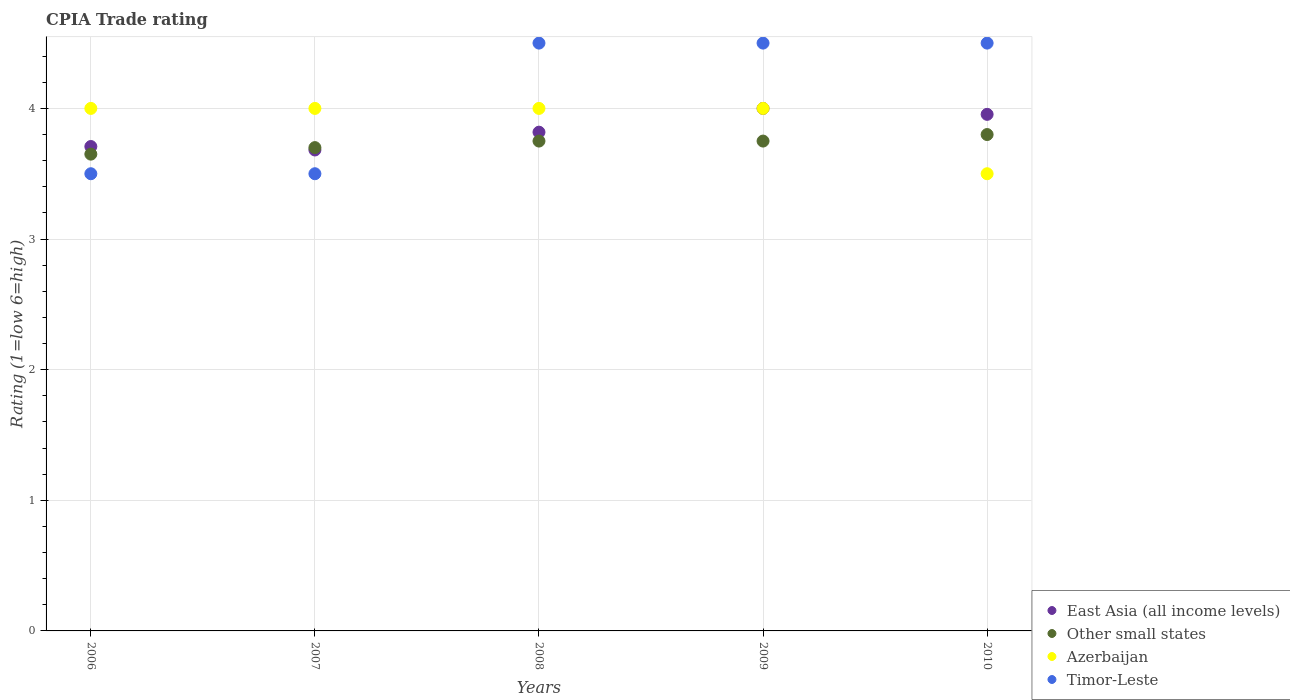How many different coloured dotlines are there?
Offer a terse response. 4. Across all years, what is the maximum CPIA rating in Timor-Leste?
Your answer should be very brief. 4.5. Across all years, what is the minimum CPIA rating in East Asia (all income levels)?
Offer a terse response. 3.68. What is the total CPIA rating in East Asia (all income levels) in the graph?
Offer a very short reply. 19.16. What is the difference between the CPIA rating in East Asia (all income levels) in 2007 and that in 2009?
Ensure brevity in your answer.  -0.32. What is the difference between the CPIA rating in Other small states in 2007 and the CPIA rating in East Asia (all income levels) in 2008?
Your response must be concise. -0.12. What is the average CPIA rating in Timor-Leste per year?
Make the answer very short. 4.1. In the year 2009, what is the difference between the CPIA rating in Other small states and CPIA rating in East Asia (all income levels)?
Offer a very short reply. -0.25. In how many years, is the CPIA rating in Other small states greater than 1?
Offer a very short reply. 5. What is the ratio of the CPIA rating in Timor-Leste in 2008 to that in 2010?
Make the answer very short. 1. What is the difference between the highest and the lowest CPIA rating in Other small states?
Your answer should be compact. 0.15. Is the sum of the CPIA rating in Azerbaijan in 2006 and 2008 greater than the maximum CPIA rating in East Asia (all income levels) across all years?
Keep it short and to the point. Yes. Is it the case that in every year, the sum of the CPIA rating in Azerbaijan and CPIA rating in East Asia (all income levels)  is greater than the sum of CPIA rating in Other small states and CPIA rating in Timor-Leste?
Make the answer very short. No. Does the CPIA rating in Other small states monotonically increase over the years?
Ensure brevity in your answer.  No. Is the CPIA rating in Other small states strictly greater than the CPIA rating in Azerbaijan over the years?
Ensure brevity in your answer.  No. Is the CPIA rating in East Asia (all income levels) strictly less than the CPIA rating in Timor-Leste over the years?
Give a very brief answer. No. How many years are there in the graph?
Your answer should be very brief. 5. Does the graph contain any zero values?
Offer a terse response. No. How many legend labels are there?
Ensure brevity in your answer.  4. How are the legend labels stacked?
Offer a very short reply. Vertical. What is the title of the graph?
Provide a short and direct response. CPIA Trade rating. What is the label or title of the Y-axis?
Keep it short and to the point. Rating (1=low 6=high). What is the Rating (1=low 6=high) of East Asia (all income levels) in 2006?
Keep it short and to the point. 3.71. What is the Rating (1=low 6=high) in Other small states in 2006?
Your answer should be compact. 3.65. What is the Rating (1=low 6=high) in Azerbaijan in 2006?
Ensure brevity in your answer.  4. What is the Rating (1=low 6=high) in East Asia (all income levels) in 2007?
Your answer should be compact. 3.68. What is the Rating (1=low 6=high) in East Asia (all income levels) in 2008?
Your response must be concise. 3.82. What is the Rating (1=low 6=high) of Other small states in 2008?
Keep it short and to the point. 3.75. What is the Rating (1=low 6=high) in Timor-Leste in 2008?
Provide a succinct answer. 4.5. What is the Rating (1=low 6=high) of East Asia (all income levels) in 2009?
Your response must be concise. 4. What is the Rating (1=low 6=high) in Other small states in 2009?
Make the answer very short. 3.75. What is the Rating (1=low 6=high) of East Asia (all income levels) in 2010?
Offer a very short reply. 3.95. What is the Rating (1=low 6=high) of Other small states in 2010?
Your answer should be very brief. 3.8. What is the Rating (1=low 6=high) of Azerbaijan in 2010?
Make the answer very short. 3.5. What is the Rating (1=low 6=high) in Timor-Leste in 2010?
Offer a terse response. 4.5. Across all years, what is the maximum Rating (1=low 6=high) in East Asia (all income levels)?
Your response must be concise. 4. Across all years, what is the maximum Rating (1=low 6=high) of Timor-Leste?
Provide a succinct answer. 4.5. Across all years, what is the minimum Rating (1=low 6=high) of East Asia (all income levels)?
Offer a terse response. 3.68. Across all years, what is the minimum Rating (1=low 6=high) of Other small states?
Your answer should be very brief. 3.65. Across all years, what is the minimum Rating (1=low 6=high) of Timor-Leste?
Provide a succinct answer. 3.5. What is the total Rating (1=low 6=high) in East Asia (all income levels) in the graph?
Give a very brief answer. 19.16. What is the total Rating (1=low 6=high) of Other small states in the graph?
Offer a very short reply. 18.65. What is the total Rating (1=low 6=high) in Azerbaijan in the graph?
Give a very brief answer. 19.5. What is the difference between the Rating (1=low 6=high) in East Asia (all income levels) in 2006 and that in 2007?
Offer a terse response. 0.03. What is the difference between the Rating (1=low 6=high) in East Asia (all income levels) in 2006 and that in 2008?
Ensure brevity in your answer.  -0.11. What is the difference between the Rating (1=low 6=high) in Other small states in 2006 and that in 2008?
Your answer should be very brief. -0.1. What is the difference between the Rating (1=low 6=high) of Azerbaijan in 2006 and that in 2008?
Make the answer very short. 0. What is the difference between the Rating (1=low 6=high) in Timor-Leste in 2006 and that in 2008?
Offer a terse response. -1. What is the difference between the Rating (1=low 6=high) in East Asia (all income levels) in 2006 and that in 2009?
Ensure brevity in your answer.  -0.29. What is the difference between the Rating (1=low 6=high) of Azerbaijan in 2006 and that in 2009?
Give a very brief answer. 0. What is the difference between the Rating (1=low 6=high) in East Asia (all income levels) in 2006 and that in 2010?
Keep it short and to the point. -0.25. What is the difference between the Rating (1=low 6=high) in Other small states in 2006 and that in 2010?
Ensure brevity in your answer.  -0.15. What is the difference between the Rating (1=low 6=high) of Timor-Leste in 2006 and that in 2010?
Provide a succinct answer. -1. What is the difference between the Rating (1=low 6=high) in East Asia (all income levels) in 2007 and that in 2008?
Provide a succinct answer. -0.14. What is the difference between the Rating (1=low 6=high) of Azerbaijan in 2007 and that in 2008?
Your response must be concise. 0. What is the difference between the Rating (1=low 6=high) in East Asia (all income levels) in 2007 and that in 2009?
Ensure brevity in your answer.  -0.32. What is the difference between the Rating (1=low 6=high) in Other small states in 2007 and that in 2009?
Make the answer very short. -0.05. What is the difference between the Rating (1=low 6=high) of Timor-Leste in 2007 and that in 2009?
Offer a very short reply. -1. What is the difference between the Rating (1=low 6=high) in East Asia (all income levels) in 2007 and that in 2010?
Provide a succinct answer. -0.27. What is the difference between the Rating (1=low 6=high) in Other small states in 2007 and that in 2010?
Keep it short and to the point. -0.1. What is the difference between the Rating (1=low 6=high) of East Asia (all income levels) in 2008 and that in 2009?
Ensure brevity in your answer.  -0.18. What is the difference between the Rating (1=low 6=high) of Azerbaijan in 2008 and that in 2009?
Provide a succinct answer. 0. What is the difference between the Rating (1=low 6=high) in East Asia (all income levels) in 2008 and that in 2010?
Give a very brief answer. -0.14. What is the difference between the Rating (1=low 6=high) in Other small states in 2008 and that in 2010?
Your response must be concise. -0.05. What is the difference between the Rating (1=low 6=high) of Azerbaijan in 2008 and that in 2010?
Ensure brevity in your answer.  0.5. What is the difference between the Rating (1=low 6=high) in Timor-Leste in 2008 and that in 2010?
Ensure brevity in your answer.  0. What is the difference between the Rating (1=low 6=high) of East Asia (all income levels) in 2009 and that in 2010?
Ensure brevity in your answer.  0.05. What is the difference between the Rating (1=low 6=high) in East Asia (all income levels) in 2006 and the Rating (1=low 6=high) in Other small states in 2007?
Provide a succinct answer. 0.01. What is the difference between the Rating (1=low 6=high) in East Asia (all income levels) in 2006 and the Rating (1=low 6=high) in Azerbaijan in 2007?
Keep it short and to the point. -0.29. What is the difference between the Rating (1=low 6=high) of East Asia (all income levels) in 2006 and the Rating (1=low 6=high) of Timor-Leste in 2007?
Provide a short and direct response. 0.21. What is the difference between the Rating (1=low 6=high) in Other small states in 2006 and the Rating (1=low 6=high) in Azerbaijan in 2007?
Make the answer very short. -0.35. What is the difference between the Rating (1=low 6=high) in Other small states in 2006 and the Rating (1=low 6=high) in Timor-Leste in 2007?
Offer a terse response. 0.15. What is the difference between the Rating (1=low 6=high) in East Asia (all income levels) in 2006 and the Rating (1=low 6=high) in Other small states in 2008?
Your response must be concise. -0.04. What is the difference between the Rating (1=low 6=high) in East Asia (all income levels) in 2006 and the Rating (1=low 6=high) in Azerbaijan in 2008?
Offer a very short reply. -0.29. What is the difference between the Rating (1=low 6=high) of East Asia (all income levels) in 2006 and the Rating (1=low 6=high) of Timor-Leste in 2008?
Ensure brevity in your answer.  -0.79. What is the difference between the Rating (1=low 6=high) in Other small states in 2006 and the Rating (1=low 6=high) in Azerbaijan in 2008?
Your answer should be compact. -0.35. What is the difference between the Rating (1=low 6=high) of Other small states in 2006 and the Rating (1=low 6=high) of Timor-Leste in 2008?
Your response must be concise. -0.85. What is the difference between the Rating (1=low 6=high) in Azerbaijan in 2006 and the Rating (1=low 6=high) in Timor-Leste in 2008?
Your answer should be very brief. -0.5. What is the difference between the Rating (1=low 6=high) of East Asia (all income levels) in 2006 and the Rating (1=low 6=high) of Other small states in 2009?
Give a very brief answer. -0.04. What is the difference between the Rating (1=low 6=high) in East Asia (all income levels) in 2006 and the Rating (1=low 6=high) in Azerbaijan in 2009?
Provide a succinct answer. -0.29. What is the difference between the Rating (1=low 6=high) in East Asia (all income levels) in 2006 and the Rating (1=low 6=high) in Timor-Leste in 2009?
Provide a succinct answer. -0.79. What is the difference between the Rating (1=low 6=high) in Other small states in 2006 and the Rating (1=low 6=high) in Azerbaijan in 2009?
Make the answer very short. -0.35. What is the difference between the Rating (1=low 6=high) of Other small states in 2006 and the Rating (1=low 6=high) of Timor-Leste in 2009?
Give a very brief answer. -0.85. What is the difference between the Rating (1=low 6=high) of Azerbaijan in 2006 and the Rating (1=low 6=high) of Timor-Leste in 2009?
Make the answer very short. -0.5. What is the difference between the Rating (1=low 6=high) of East Asia (all income levels) in 2006 and the Rating (1=low 6=high) of Other small states in 2010?
Make the answer very short. -0.09. What is the difference between the Rating (1=low 6=high) in East Asia (all income levels) in 2006 and the Rating (1=low 6=high) in Azerbaijan in 2010?
Offer a terse response. 0.21. What is the difference between the Rating (1=low 6=high) of East Asia (all income levels) in 2006 and the Rating (1=low 6=high) of Timor-Leste in 2010?
Provide a succinct answer. -0.79. What is the difference between the Rating (1=low 6=high) in Other small states in 2006 and the Rating (1=low 6=high) in Timor-Leste in 2010?
Provide a short and direct response. -0.85. What is the difference between the Rating (1=low 6=high) in East Asia (all income levels) in 2007 and the Rating (1=low 6=high) in Other small states in 2008?
Make the answer very short. -0.07. What is the difference between the Rating (1=low 6=high) in East Asia (all income levels) in 2007 and the Rating (1=low 6=high) in Azerbaijan in 2008?
Provide a short and direct response. -0.32. What is the difference between the Rating (1=low 6=high) of East Asia (all income levels) in 2007 and the Rating (1=low 6=high) of Timor-Leste in 2008?
Your response must be concise. -0.82. What is the difference between the Rating (1=low 6=high) in Other small states in 2007 and the Rating (1=low 6=high) in Azerbaijan in 2008?
Offer a terse response. -0.3. What is the difference between the Rating (1=low 6=high) of East Asia (all income levels) in 2007 and the Rating (1=low 6=high) of Other small states in 2009?
Offer a terse response. -0.07. What is the difference between the Rating (1=low 6=high) of East Asia (all income levels) in 2007 and the Rating (1=low 6=high) of Azerbaijan in 2009?
Your response must be concise. -0.32. What is the difference between the Rating (1=low 6=high) of East Asia (all income levels) in 2007 and the Rating (1=low 6=high) of Timor-Leste in 2009?
Make the answer very short. -0.82. What is the difference between the Rating (1=low 6=high) in East Asia (all income levels) in 2007 and the Rating (1=low 6=high) in Other small states in 2010?
Provide a succinct answer. -0.12. What is the difference between the Rating (1=low 6=high) of East Asia (all income levels) in 2007 and the Rating (1=low 6=high) of Azerbaijan in 2010?
Make the answer very short. 0.18. What is the difference between the Rating (1=low 6=high) of East Asia (all income levels) in 2007 and the Rating (1=low 6=high) of Timor-Leste in 2010?
Keep it short and to the point. -0.82. What is the difference between the Rating (1=low 6=high) of Other small states in 2007 and the Rating (1=low 6=high) of Azerbaijan in 2010?
Provide a succinct answer. 0.2. What is the difference between the Rating (1=low 6=high) in East Asia (all income levels) in 2008 and the Rating (1=low 6=high) in Other small states in 2009?
Offer a terse response. 0.07. What is the difference between the Rating (1=low 6=high) in East Asia (all income levels) in 2008 and the Rating (1=low 6=high) in Azerbaijan in 2009?
Provide a short and direct response. -0.18. What is the difference between the Rating (1=low 6=high) in East Asia (all income levels) in 2008 and the Rating (1=low 6=high) in Timor-Leste in 2009?
Ensure brevity in your answer.  -0.68. What is the difference between the Rating (1=low 6=high) in Other small states in 2008 and the Rating (1=low 6=high) in Timor-Leste in 2009?
Keep it short and to the point. -0.75. What is the difference between the Rating (1=low 6=high) of Azerbaijan in 2008 and the Rating (1=low 6=high) of Timor-Leste in 2009?
Your answer should be compact. -0.5. What is the difference between the Rating (1=low 6=high) in East Asia (all income levels) in 2008 and the Rating (1=low 6=high) in Other small states in 2010?
Provide a short and direct response. 0.02. What is the difference between the Rating (1=low 6=high) of East Asia (all income levels) in 2008 and the Rating (1=low 6=high) of Azerbaijan in 2010?
Your answer should be very brief. 0.32. What is the difference between the Rating (1=low 6=high) in East Asia (all income levels) in 2008 and the Rating (1=low 6=high) in Timor-Leste in 2010?
Your answer should be compact. -0.68. What is the difference between the Rating (1=low 6=high) in Other small states in 2008 and the Rating (1=low 6=high) in Timor-Leste in 2010?
Your answer should be compact. -0.75. What is the difference between the Rating (1=low 6=high) in Azerbaijan in 2008 and the Rating (1=low 6=high) in Timor-Leste in 2010?
Provide a short and direct response. -0.5. What is the difference between the Rating (1=low 6=high) of East Asia (all income levels) in 2009 and the Rating (1=low 6=high) of Other small states in 2010?
Your response must be concise. 0.2. What is the difference between the Rating (1=low 6=high) in East Asia (all income levels) in 2009 and the Rating (1=low 6=high) in Timor-Leste in 2010?
Offer a terse response. -0.5. What is the difference between the Rating (1=low 6=high) of Other small states in 2009 and the Rating (1=low 6=high) of Azerbaijan in 2010?
Offer a very short reply. 0.25. What is the difference between the Rating (1=low 6=high) of Other small states in 2009 and the Rating (1=low 6=high) of Timor-Leste in 2010?
Give a very brief answer. -0.75. What is the difference between the Rating (1=low 6=high) in Azerbaijan in 2009 and the Rating (1=low 6=high) in Timor-Leste in 2010?
Your answer should be compact. -0.5. What is the average Rating (1=low 6=high) in East Asia (all income levels) per year?
Provide a succinct answer. 3.83. What is the average Rating (1=low 6=high) of Other small states per year?
Provide a short and direct response. 3.73. What is the average Rating (1=low 6=high) of Azerbaijan per year?
Keep it short and to the point. 3.9. In the year 2006, what is the difference between the Rating (1=low 6=high) in East Asia (all income levels) and Rating (1=low 6=high) in Other small states?
Provide a succinct answer. 0.06. In the year 2006, what is the difference between the Rating (1=low 6=high) of East Asia (all income levels) and Rating (1=low 6=high) of Azerbaijan?
Provide a succinct answer. -0.29. In the year 2006, what is the difference between the Rating (1=low 6=high) in East Asia (all income levels) and Rating (1=low 6=high) in Timor-Leste?
Ensure brevity in your answer.  0.21. In the year 2006, what is the difference between the Rating (1=low 6=high) in Other small states and Rating (1=low 6=high) in Azerbaijan?
Your answer should be very brief. -0.35. In the year 2007, what is the difference between the Rating (1=low 6=high) in East Asia (all income levels) and Rating (1=low 6=high) in Other small states?
Offer a terse response. -0.02. In the year 2007, what is the difference between the Rating (1=low 6=high) in East Asia (all income levels) and Rating (1=low 6=high) in Azerbaijan?
Provide a succinct answer. -0.32. In the year 2007, what is the difference between the Rating (1=low 6=high) in East Asia (all income levels) and Rating (1=low 6=high) in Timor-Leste?
Provide a short and direct response. 0.18. In the year 2007, what is the difference between the Rating (1=low 6=high) in Other small states and Rating (1=low 6=high) in Azerbaijan?
Give a very brief answer. -0.3. In the year 2007, what is the difference between the Rating (1=low 6=high) in Other small states and Rating (1=low 6=high) in Timor-Leste?
Your answer should be very brief. 0.2. In the year 2007, what is the difference between the Rating (1=low 6=high) in Azerbaijan and Rating (1=low 6=high) in Timor-Leste?
Offer a terse response. 0.5. In the year 2008, what is the difference between the Rating (1=low 6=high) of East Asia (all income levels) and Rating (1=low 6=high) of Other small states?
Keep it short and to the point. 0.07. In the year 2008, what is the difference between the Rating (1=low 6=high) in East Asia (all income levels) and Rating (1=low 6=high) in Azerbaijan?
Your answer should be compact. -0.18. In the year 2008, what is the difference between the Rating (1=low 6=high) of East Asia (all income levels) and Rating (1=low 6=high) of Timor-Leste?
Ensure brevity in your answer.  -0.68. In the year 2008, what is the difference between the Rating (1=low 6=high) of Other small states and Rating (1=low 6=high) of Azerbaijan?
Provide a succinct answer. -0.25. In the year 2008, what is the difference between the Rating (1=low 6=high) in Other small states and Rating (1=low 6=high) in Timor-Leste?
Offer a very short reply. -0.75. In the year 2009, what is the difference between the Rating (1=low 6=high) of East Asia (all income levels) and Rating (1=low 6=high) of Azerbaijan?
Your answer should be compact. 0. In the year 2009, what is the difference between the Rating (1=low 6=high) of Other small states and Rating (1=low 6=high) of Timor-Leste?
Make the answer very short. -0.75. In the year 2009, what is the difference between the Rating (1=low 6=high) in Azerbaijan and Rating (1=low 6=high) in Timor-Leste?
Your response must be concise. -0.5. In the year 2010, what is the difference between the Rating (1=low 6=high) in East Asia (all income levels) and Rating (1=low 6=high) in Other small states?
Make the answer very short. 0.15. In the year 2010, what is the difference between the Rating (1=low 6=high) in East Asia (all income levels) and Rating (1=low 6=high) in Azerbaijan?
Your answer should be very brief. 0.45. In the year 2010, what is the difference between the Rating (1=low 6=high) of East Asia (all income levels) and Rating (1=low 6=high) of Timor-Leste?
Provide a short and direct response. -0.55. What is the ratio of the Rating (1=low 6=high) in Other small states in 2006 to that in 2007?
Give a very brief answer. 0.99. What is the ratio of the Rating (1=low 6=high) in Timor-Leste in 2006 to that in 2007?
Keep it short and to the point. 1. What is the ratio of the Rating (1=low 6=high) of East Asia (all income levels) in 2006 to that in 2008?
Offer a terse response. 0.97. What is the ratio of the Rating (1=low 6=high) in Other small states in 2006 to that in 2008?
Ensure brevity in your answer.  0.97. What is the ratio of the Rating (1=low 6=high) in Azerbaijan in 2006 to that in 2008?
Give a very brief answer. 1. What is the ratio of the Rating (1=low 6=high) in Timor-Leste in 2006 to that in 2008?
Your response must be concise. 0.78. What is the ratio of the Rating (1=low 6=high) of East Asia (all income levels) in 2006 to that in 2009?
Keep it short and to the point. 0.93. What is the ratio of the Rating (1=low 6=high) of Other small states in 2006 to that in 2009?
Your response must be concise. 0.97. What is the ratio of the Rating (1=low 6=high) of East Asia (all income levels) in 2006 to that in 2010?
Provide a short and direct response. 0.94. What is the ratio of the Rating (1=low 6=high) in Other small states in 2006 to that in 2010?
Offer a terse response. 0.96. What is the ratio of the Rating (1=low 6=high) of Azerbaijan in 2006 to that in 2010?
Give a very brief answer. 1.14. What is the ratio of the Rating (1=low 6=high) in Timor-Leste in 2006 to that in 2010?
Your answer should be compact. 0.78. What is the ratio of the Rating (1=low 6=high) of East Asia (all income levels) in 2007 to that in 2008?
Your answer should be very brief. 0.96. What is the ratio of the Rating (1=low 6=high) of Other small states in 2007 to that in 2008?
Give a very brief answer. 0.99. What is the ratio of the Rating (1=low 6=high) of Azerbaijan in 2007 to that in 2008?
Offer a very short reply. 1. What is the ratio of the Rating (1=low 6=high) of East Asia (all income levels) in 2007 to that in 2009?
Keep it short and to the point. 0.92. What is the ratio of the Rating (1=low 6=high) of Other small states in 2007 to that in 2009?
Offer a very short reply. 0.99. What is the ratio of the Rating (1=low 6=high) of East Asia (all income levels) in 2007 to that in 2010?
Provide a short and direct response. 0.93. What is the ratio of the Rating (1=low 6=high) of Other small states in 2007 to that in 2010?
Provide a succinct answer. 0.97. What is the ratio of the Rating (1=low 6=high) of East Asia (all income levels) in 2008 to that in 2009?
Your answer should be very brief. 0.95. What is the ratio of the Rating (1=low 6=high) in Other small states in 2008 to that in 2009?
Offer a terse response. 1. What is the ratio of the Rating (1=low 6=high) of Azerbaijan in 2008 to that in 2009?
Your answer should be very brief. 1. What is the ratio of the Rating (1=low 6=high) of Timor-Leste in 2008 to that in 2009?
Your response must be concise. 1. What is the ratio of the Rating (1=low 6=high) in East Asia (all income levels) in 2008 to that in 2010?
Give a very brief answer. 0.97. What is the ratio of the Rating (1=low 6=high) of Other small states in 2008 to that in 2010?
Offer a very short reply. 0.99. What is the ratio of the Rating (1=low 6=high) of Timor-Leste in 2008 to that in 2010?
Your answer should be compact. 1. What is the ratio of the Rating (1=low 6=high) of East Asia (all income levels) in 2009 to that in 2010?
Make the answer very short. 1.01. What is the ratio of the Rating (1=low 6=high) in Other small states in 2009 to that in 2010?
Offer a terse response. 0.99. What is the ratio of the Rating (1=low 6=high) of Timor-Leste in 2009 to that in 2010?
Provide a succinct answer. 1. What is the difference between the highest and the second highest Rating (1=low 6=high) of East Asia (all income levels)?
Your response must be concise. 0.05. What is the difference between the highest and the second highest Rating (1=low 6=high) of Other small states?
Ensure brevity in your answer.  0.05. What is the difference between the highest and the second highest Rating (1=low 6=high) of Azerbaijan?
Keep it short and to the point. 0. What is the difference between the highest and the second highest Rating (1=low 6=high) of Timor-Leste?
Offer a very short reply. 0. What is the difference between the highest and the lowest Rating (1=low 6=high) of East Asia (all income levels)?
Your response must be concise. 0.32. 